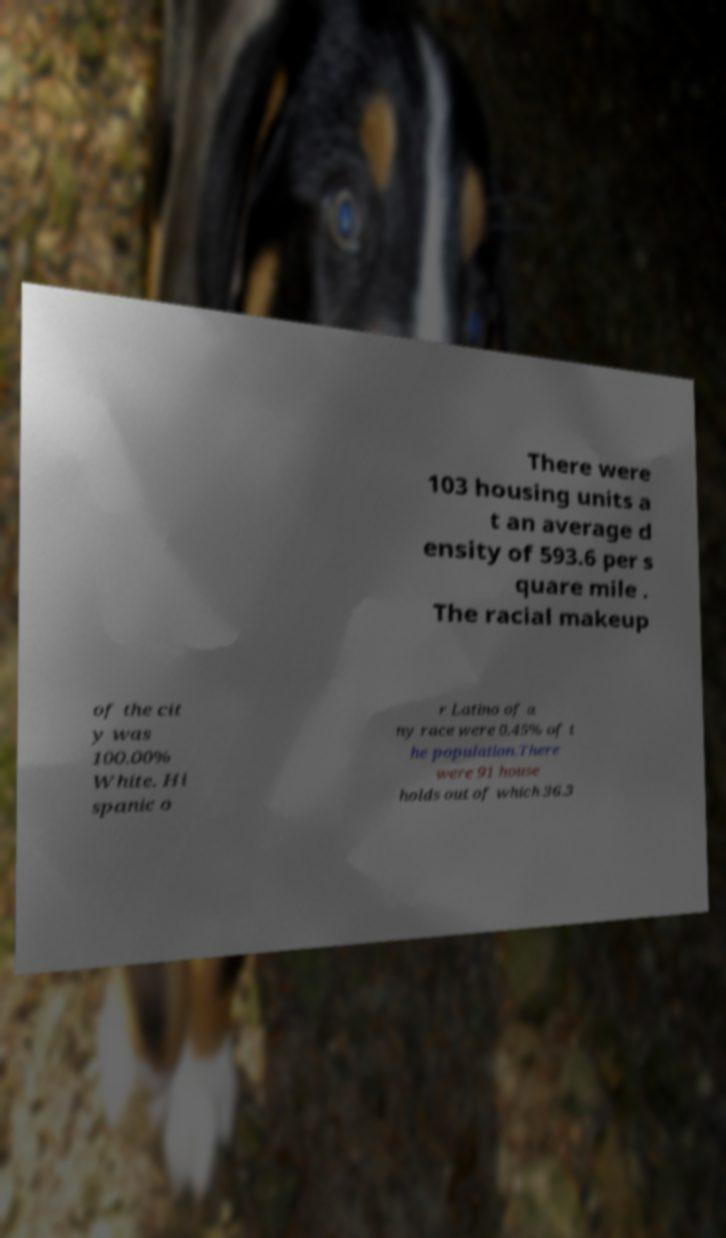Please read and relay the text visible in this image. What does it say? There were 103 housing units a t an average d ensity of 593.6 per s quare mile . The racial makeup of the cit y was 100.00% White. Hi spanic o r Latino of a ny race were 0.45% of t he population.There were 91 house holds out of which 36.3 